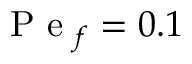Convert formula to latex. <formula><loc_0><loc_0><loc_500><loc_500>P e _ { f } = 0 . 1</formula> 